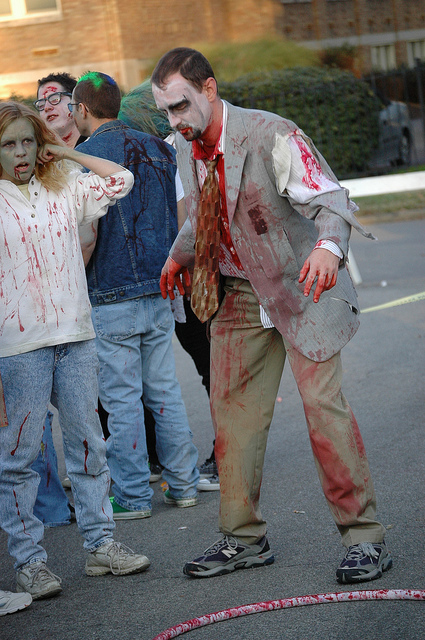How many people are there? 4 